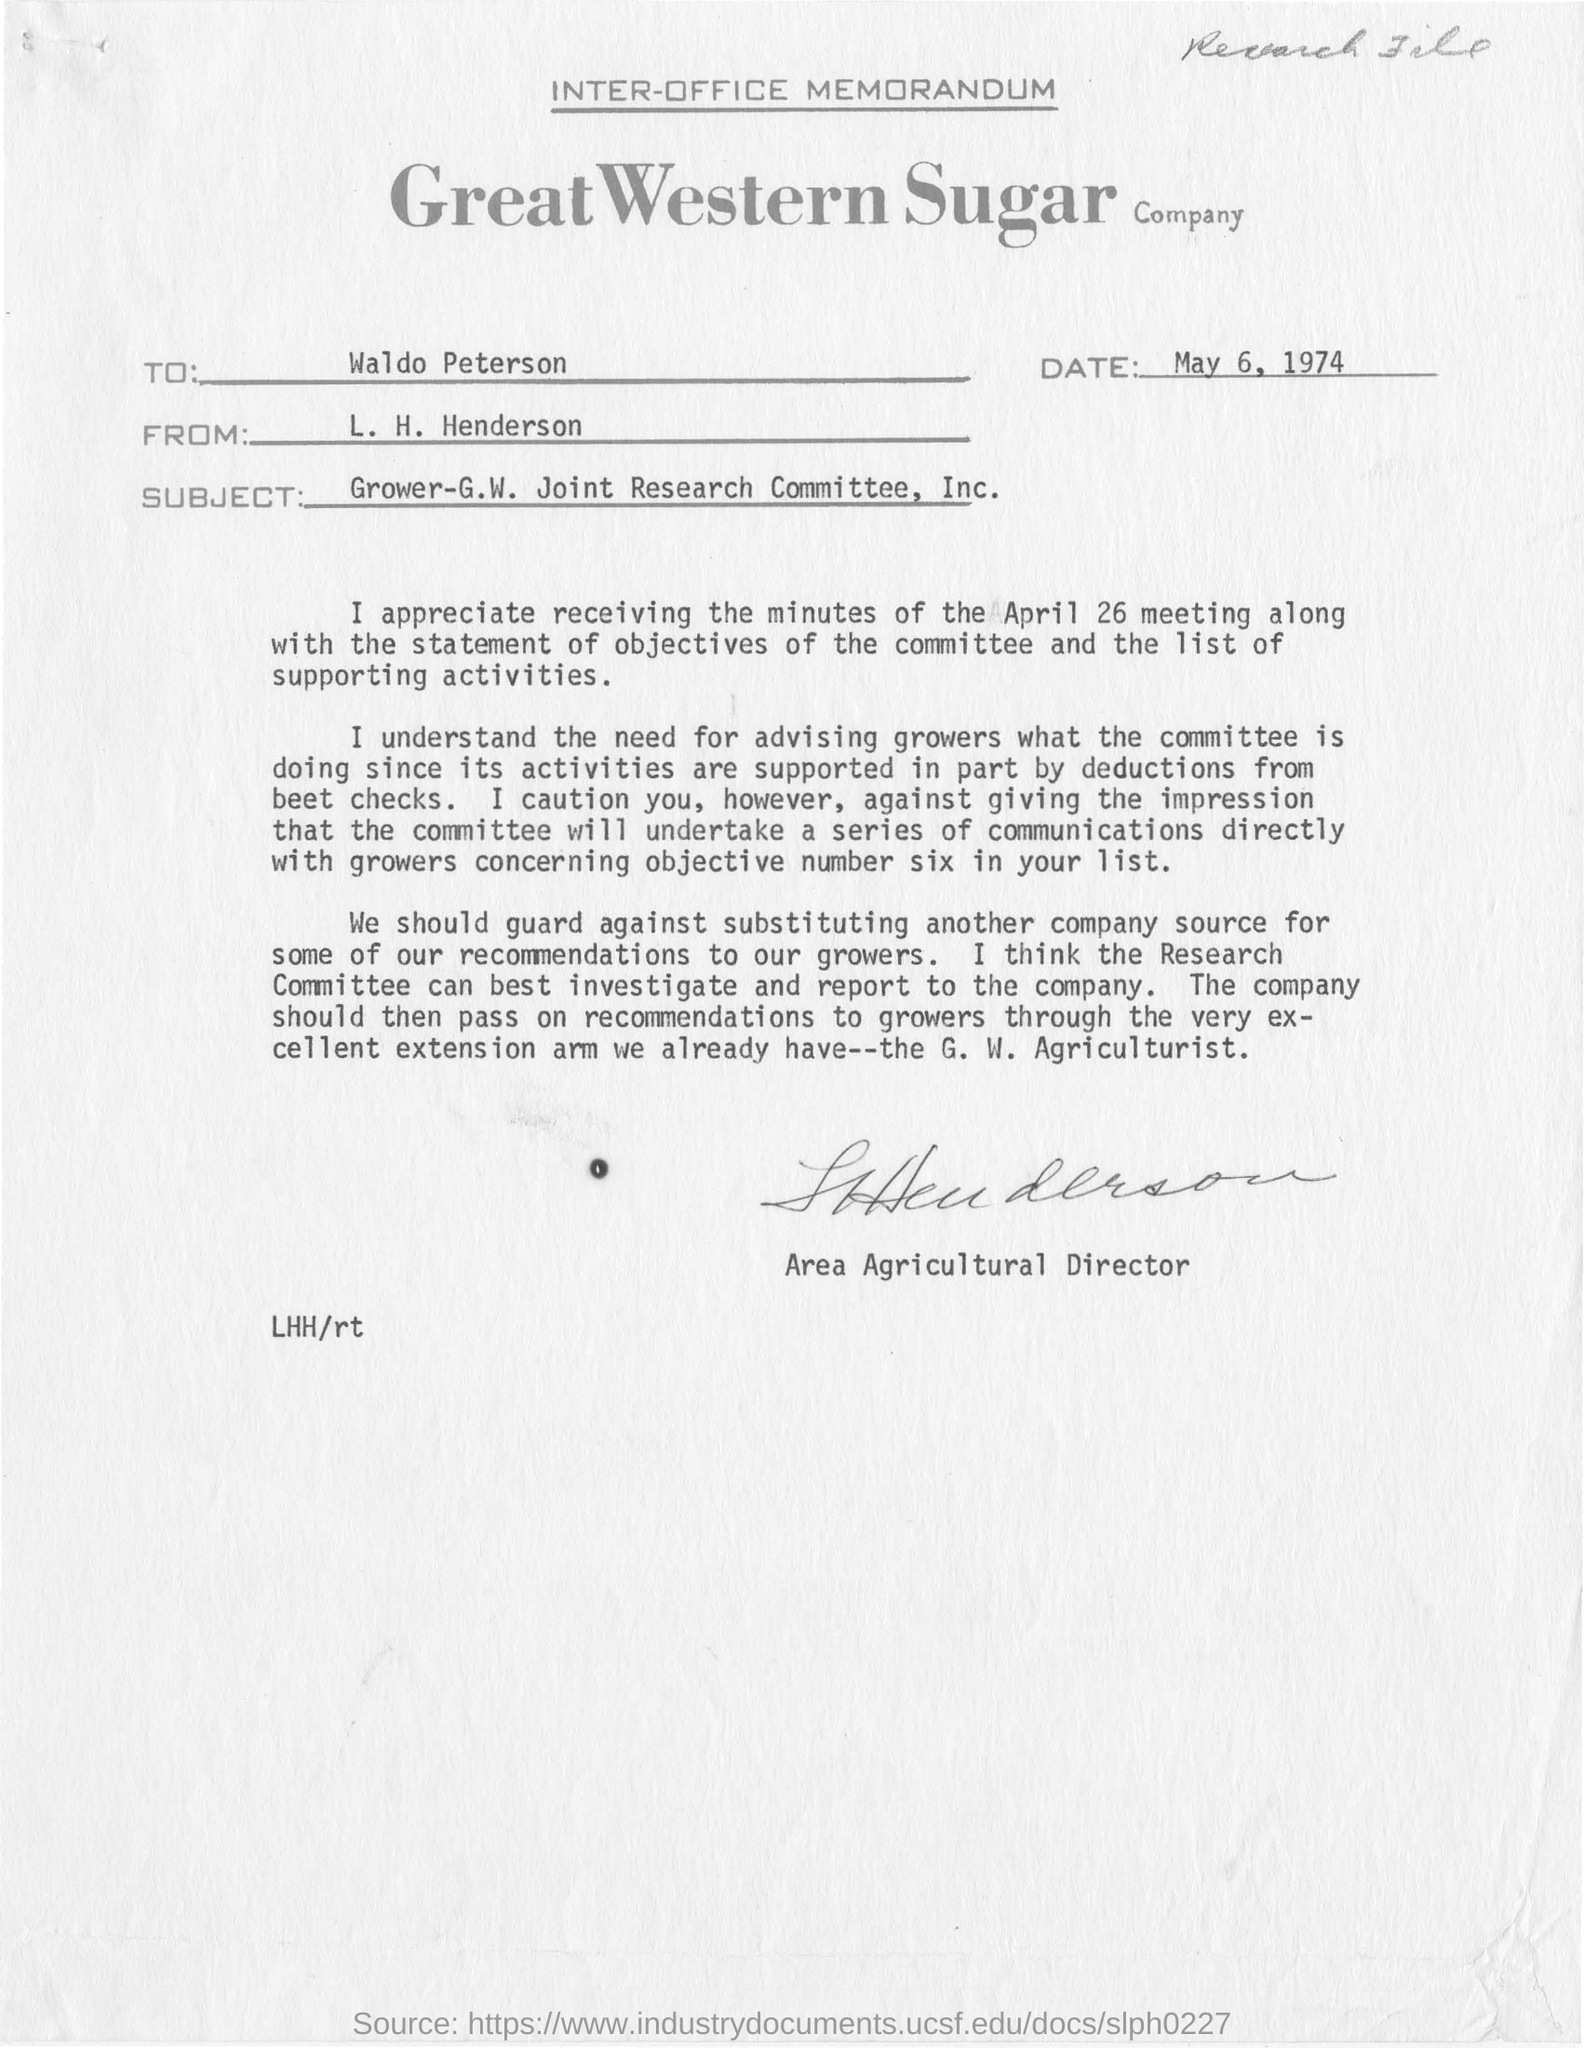Who is the sender of this memorandum?
Give a very brief answer. L. H. Henderson. To Whom is this memorandum addressed to?
Offer a very short reply. Waldo Peterson. 